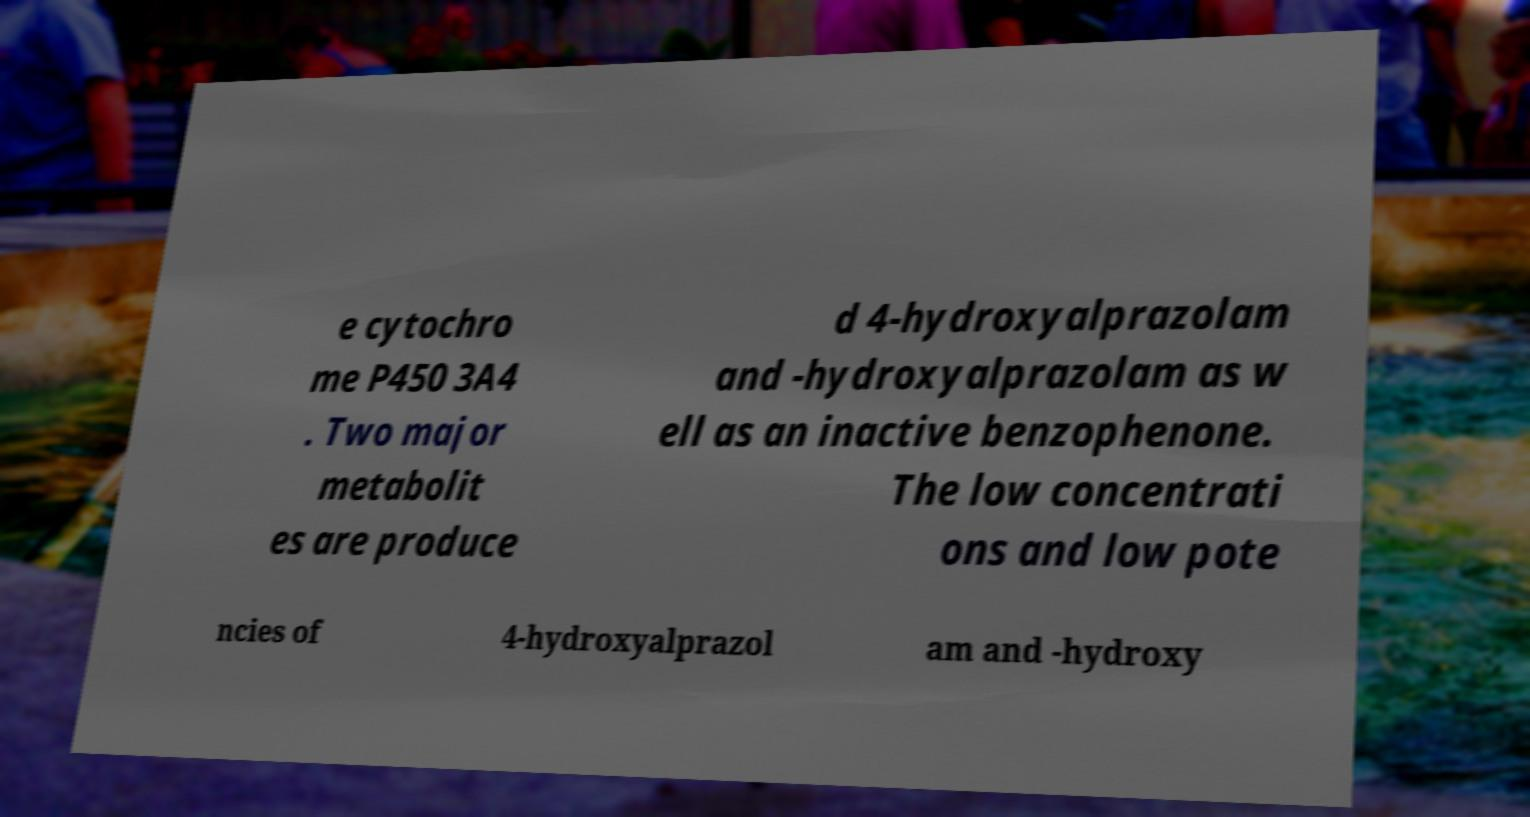Could you extract and type out the text from this image? e cytochro me P450 3A4 . Two major metabolit es are produce d 4-hydroxyalprazolam and -hydroxyalprazolam as w ell as an inactive benzophenone. The low concentrati ons and low pote ncies of 4-hydroxyalprazol am and -hydroxy 